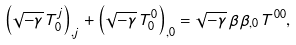<formula> <loc_0><loc_0><loc_500><loc_500>\left ( \sqrt { - \gamma } \, T _ { 0 } ^ { j } \right ) _ { , j } + \left ( \sqrt { - \gamma } \, T _ { 0 } ^ { 0 } \right ) _ { , 0 } = \sqrt { - \gamma } \, \beta \beta _ { , 0 } \, T ^ { 0 0 } ,</formula> 